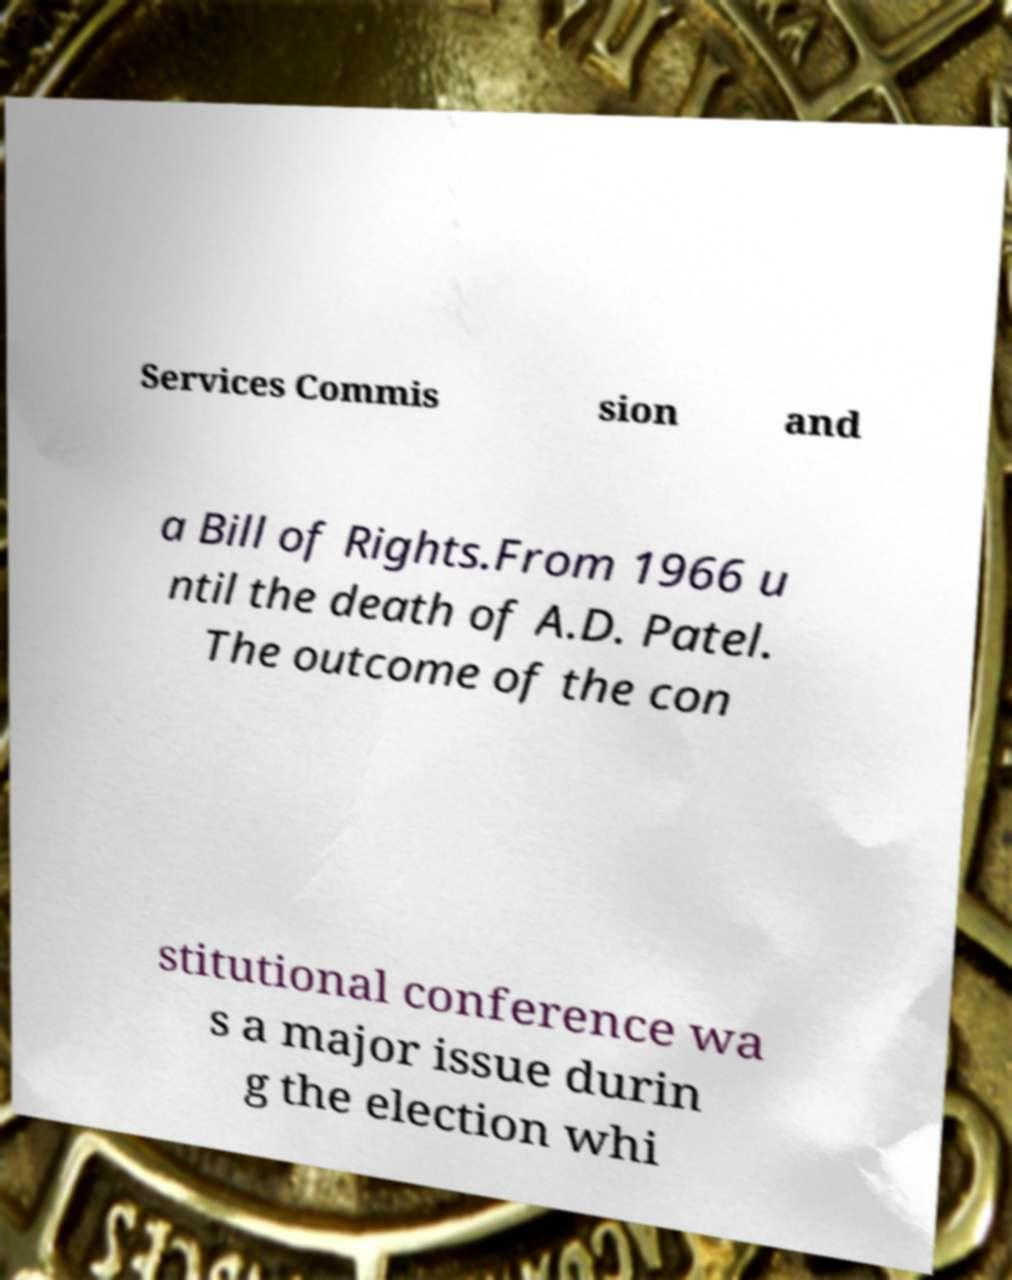Please identify and transcribe the text found in this image. Services Commis sion and a Bill of Rights.From 1966 u ntil the death of A.D. Patel. The outcome of the con stitutional conference wa s a major issue durin g the election whi 